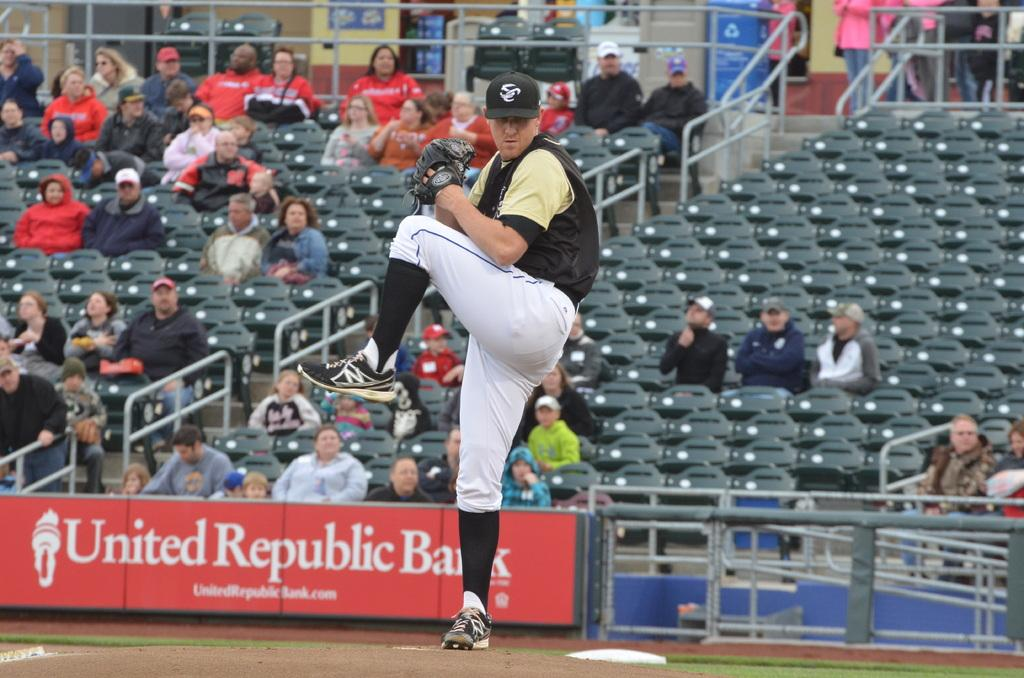<image>
Describe the image concisely. The ad in the back is for United Republic Bank 